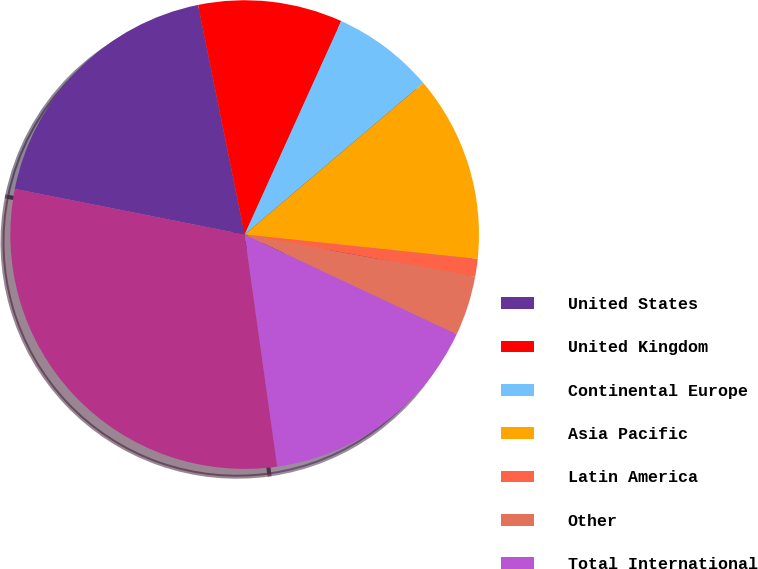Convert chart to OTSL. <chart><loc_0><loc_0><loc_500><loc_500><pie_chart><fcel>United States<fcel>United Kingdom<fcel>Continental Europe<fcel>Asia Pacific<fcel>Latin America<fcel>Other<fcel>Total International<fcel>Total Consolidated<nl><fcel>18.69%<fcel>9.95%<fcel>7.04%<fcel>12.86%<fcel>1.21%<fcel>4.13%<fcel>15.78%<fcel>30.34%<nl></chart> 